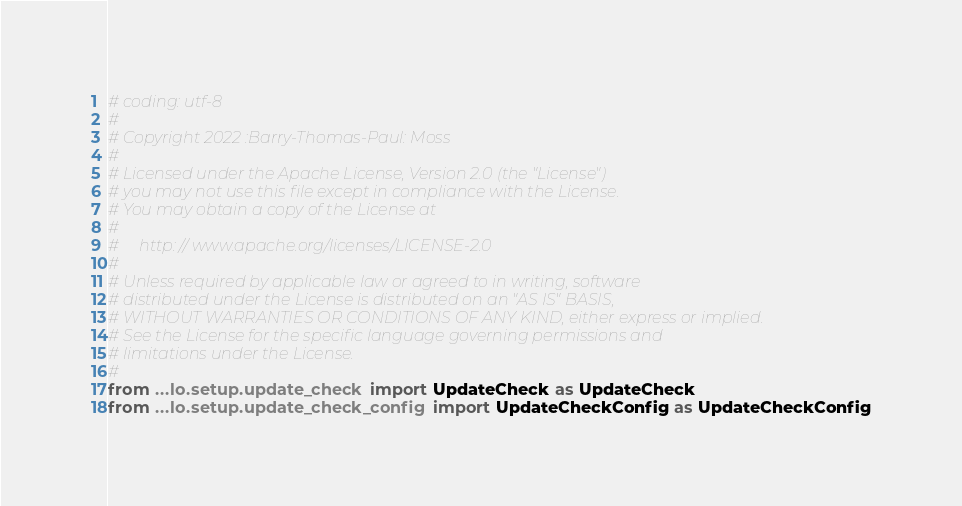<code> <loc_0><loc_0><loc_500><loc_500><_Python_># coding: utf-8
#
# Copyright 2022 :Barry-Thomas-Paul: Moss
#
# Licensed under the Apache License, Version 2.0 (the "License")
# you may not use this file except in compliance with the License.
# You may obtain a copy of the License at
#
#     http: // www.apache.org/licenses/LICENSE-2.0
#
# Unless required by applicable law or agreed to in writing, software
# distributed under the License is distributed on an "AS IS" BASIS,
# WITHOUT WARRANTIES OR CONDITIONS OF ANY KIND, either express or implied.
# See the License for the specific language governing permissions and
# limitations under the License.
#
from ...lo.setup.update_check import UpdateCheck as UpdateCheck
from ...lo.setup.update_check_config import UpdateCheckConfig as UpdateCheckConfig
</code> 